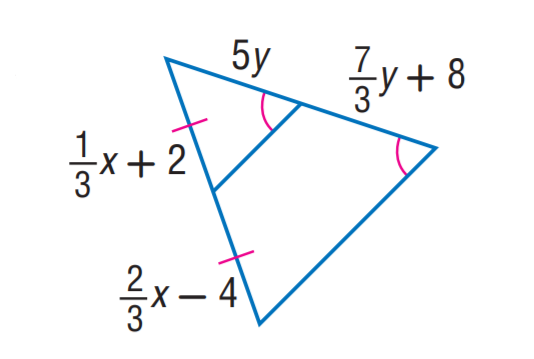Answer the mathemtical geometry problem and directly provide the correct option letter.
Question: Find x.
Choices: A: 12 B: 15 C: 18 D: 21 C 